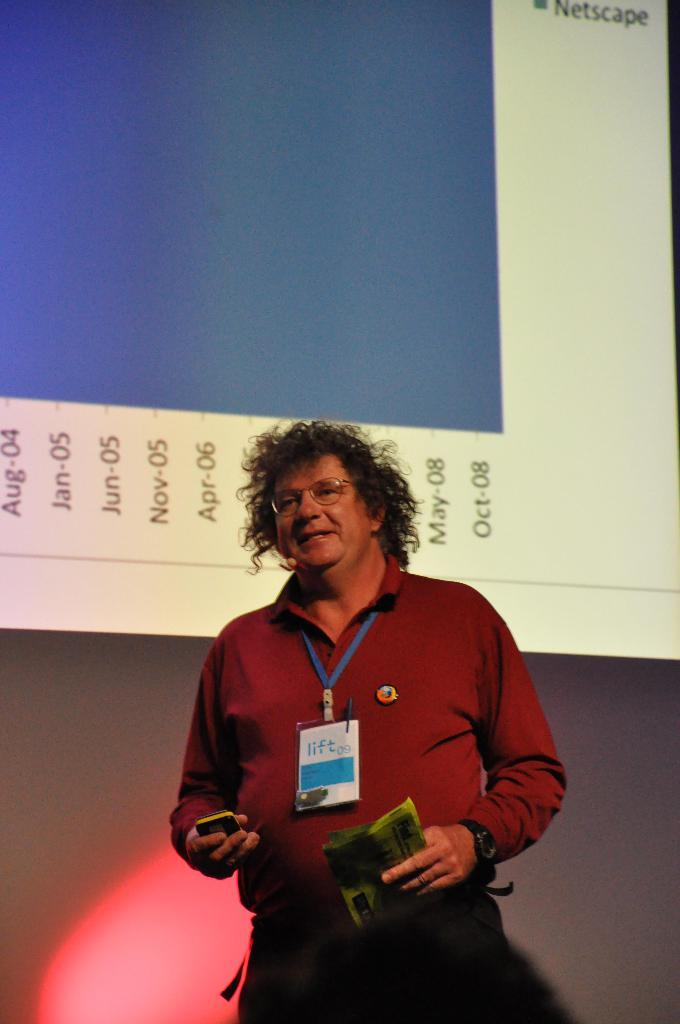Who or what is the main subject in the center of the image? There is a person in the center of the image. What is the person wearing that is visible in the image? The person is wearing ID cards. Where is the person standing in the image? The person is standing on the floor. What can be seen in the background of the image? There is a screen in the background of the image. Can you describe the other person visible in the image? There is a person's head visible at the bottom of the image. What type of bells can be heard ringing in the image? There are no bells present in the image, and therefore no sounds can be heard. Can you describe the cart that is being pulled by the duck in the image? There is no cart or duck present in the image. 